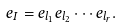Convert formula to latex. <formula><loc_0><loc_0><loc_500><loc_500>e _ { I } = e _ { l _ { 1 } } e _ { l _ { 2 } } \cdots e _ { l _ { r } } .</formula> 